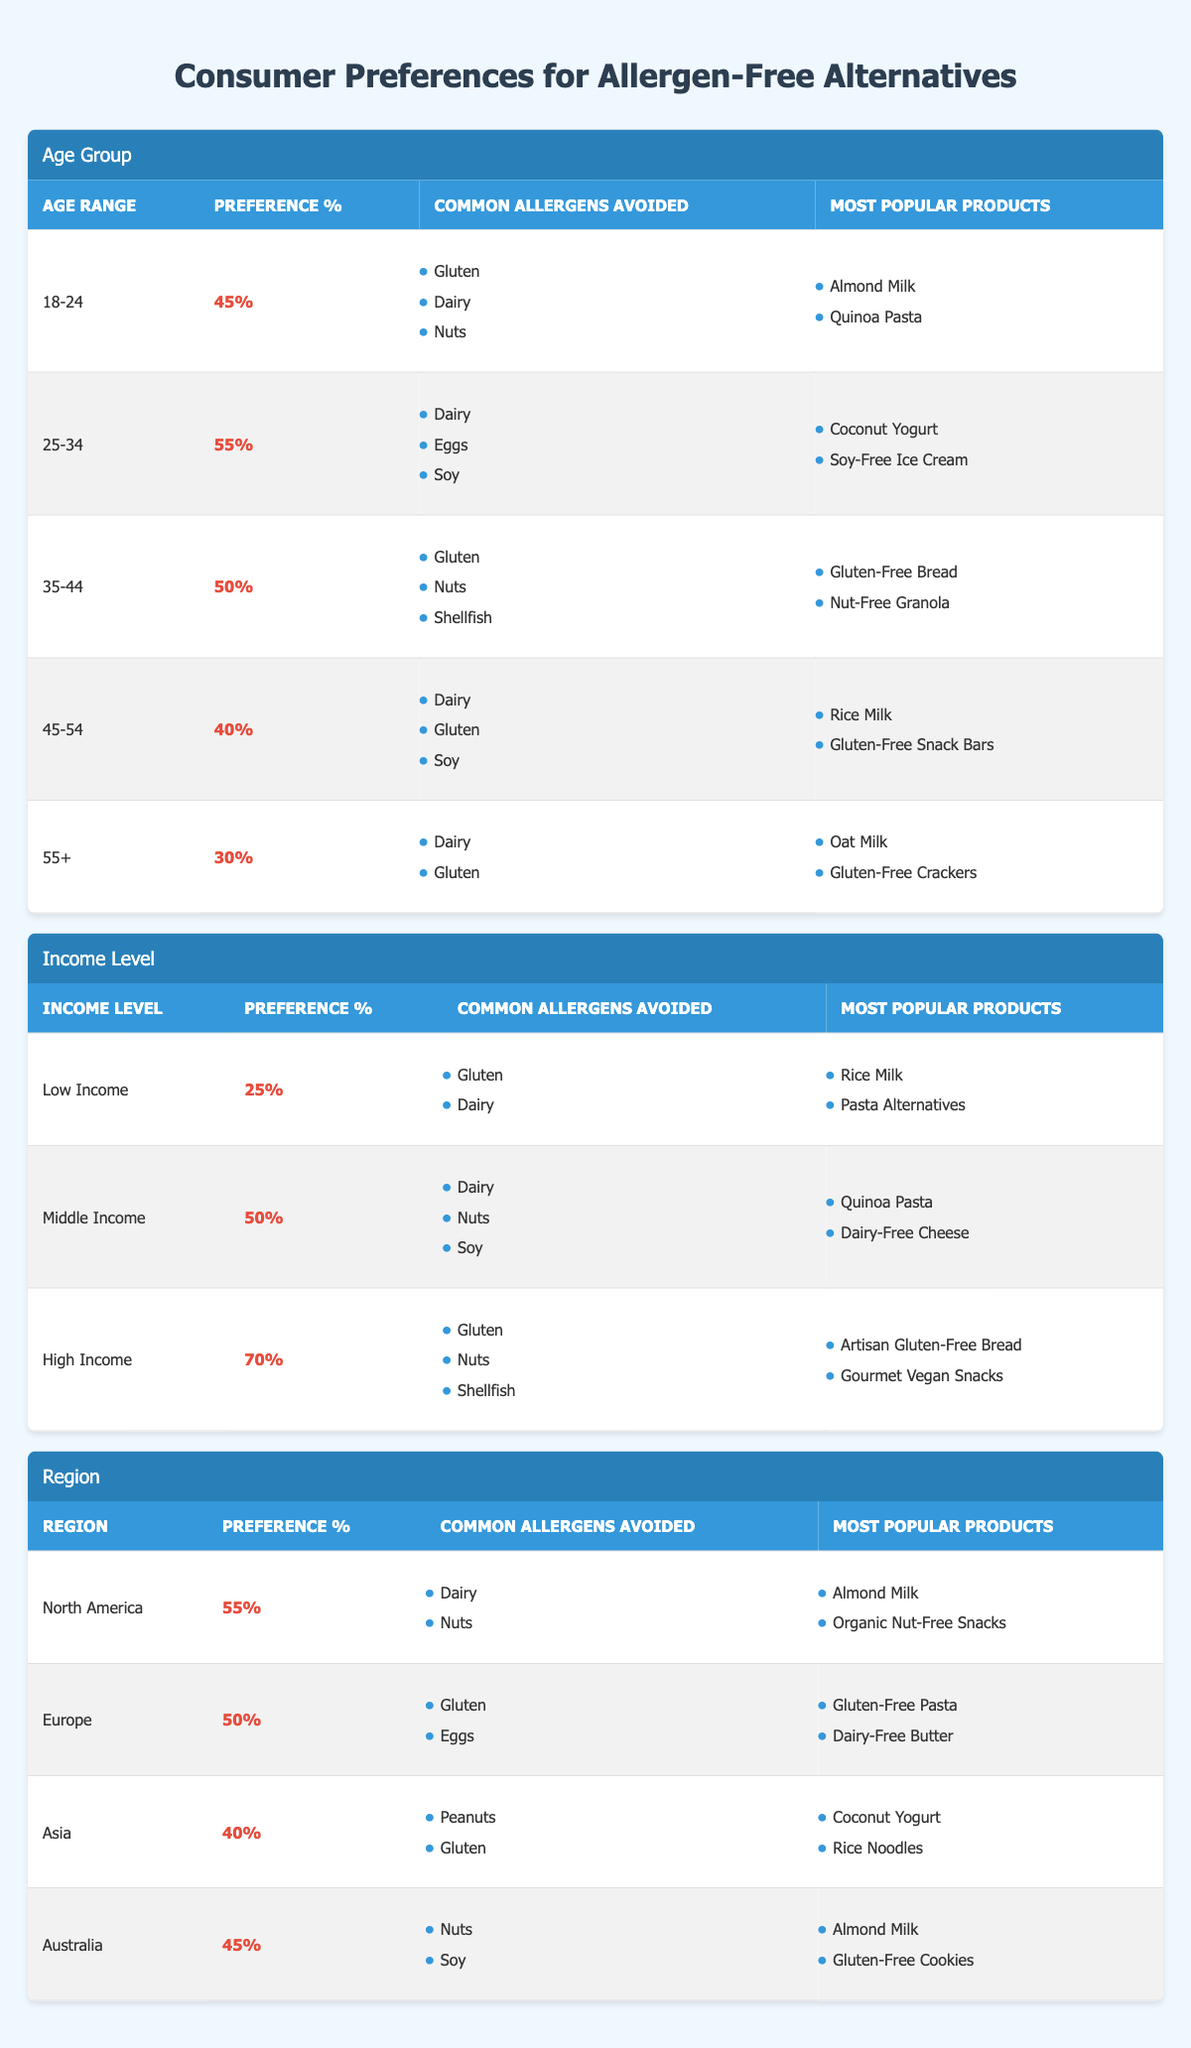What is the preference percentage for the 25-34 age group? The preference percentage for the 25-34 age group is specifically mentioned in the table under the "Age Group" section. It states 55%.
Answer: 55% Which income level has the highest preference percentage for allergen-free alternatives? The "Income Level" section of the table shows that the High Income group has a preference percentage of 70%, which is higher than both the Low Income (25%) and Middle Income (50%) groups.
Answer: High Income Are the most popular products for the 35-44 age group gluten-free? The most popular products listed for the 35-44 age group include Gluten-Free Bread and Nut-Free Granola, which indicate that yes, they are gluten-free.
Answer: Yes What are the common allergens avoided by the 18-24 age group? The information for the 18-24 age group under "Common Allergens Avoided" reveals that they avoid Gluten, Dairy, and Nuts.
Answer: Gluten, Dairy, Nuts Calculate the average preference percentage across all Age Groups listed in the table. The preference percentages for each age group are: 45%, 55%, 50%, 40%, and 30%. To find the average, we add these percentages (45 + 55 + 50 + 40 + 30 = 220) and then divide by the number of groups (220 / 5 = 44).
Answer: 44% What is the most common allergen avoided by consumers in North America? In the "Region" section, North America has Dairy and Nuts listed as common allergens avoided, which means multiple allergens are commonly avoided but Dairy is noted first in the list.
Answer: Dairy Does the preference percentage in Europe exceed that of Asia? The preference percentage for Europe is 50% and for Asia it is 40%. Since 50% is greater than 40%, the statement is true.
Answer: Yes Which age group has the lowest preference percentage for allergen-free alternatives? By comparing the percentages under the "Age Group" section, 55% (25-34) is the highest and 30% (55+) is the lowest, making 55+ the age group with lowest preference.
Answer: 55+ What income group avoids the fewest allergens according to the table? The Low Income group listed avoids Gluten and Dairy, while both Middle and High Income groups list more allergens. Moving through the income levels, Low Income avoids only two allergens.
Answer: Low Income Among all regions, which has the highest preference percentage? Comparing the preference data under the "Region" section, North America has a preference percentage of 55%, higher than the others which are 50% (Europe), 40% (Asia), and 45% (Australia).
Answer: North America 